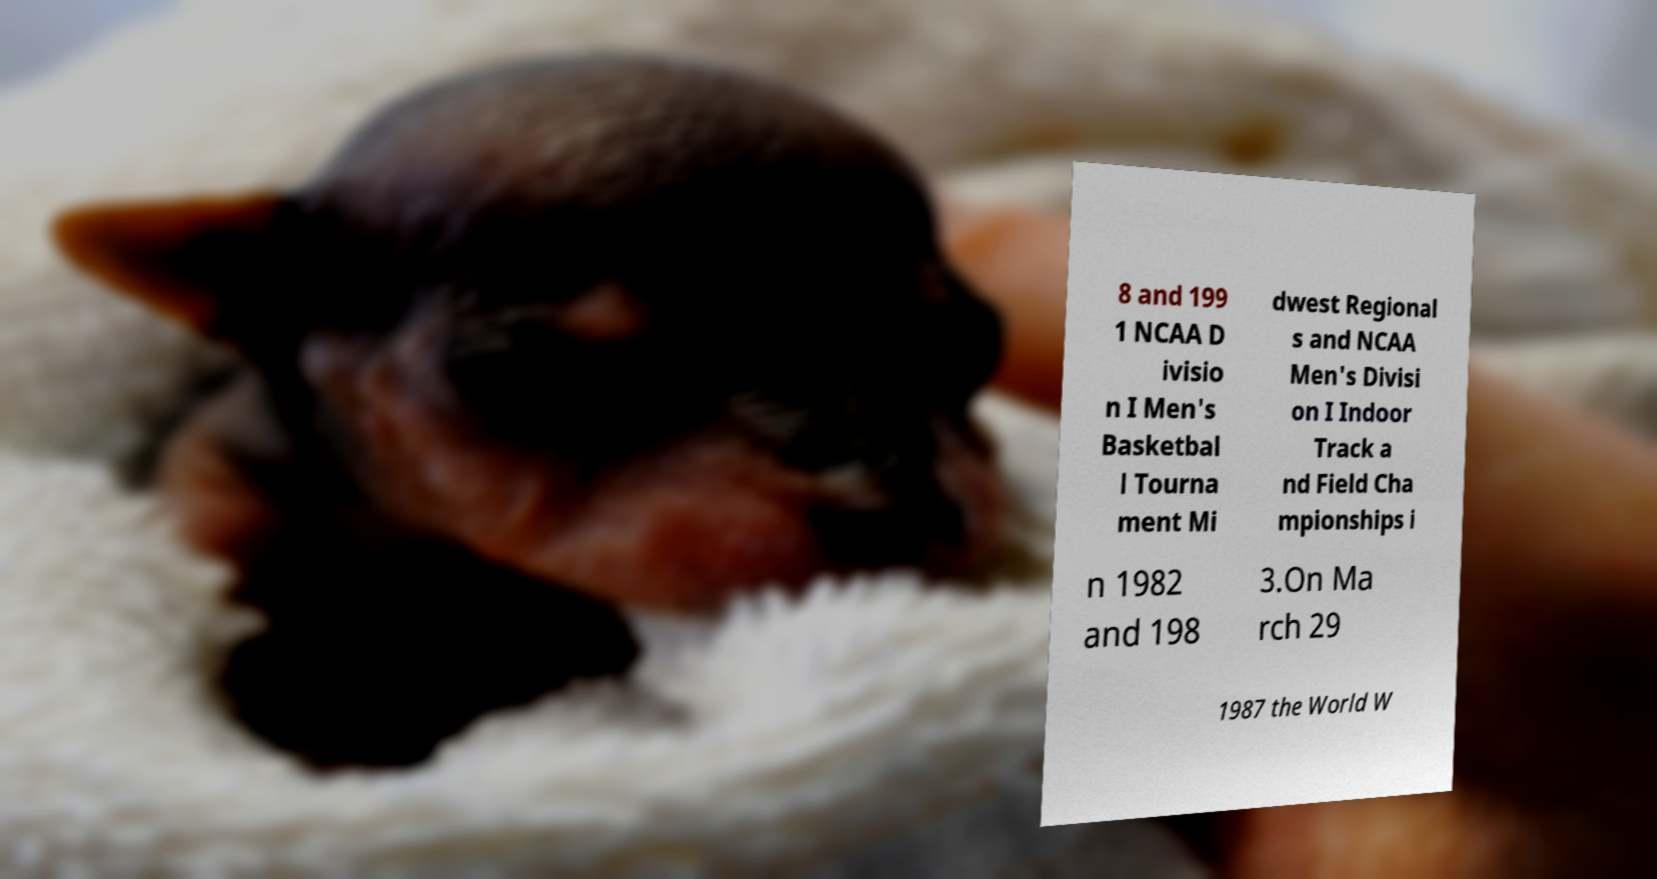Could you assist in decoding the text presented in this image and type it out clearly? 8 and 199 1 NCAA D ivisio n I Men's Basketbal l Tourna ment Mi dwest Regional s and NCAA Men's Divisi on I Indoor Track a nd Field Cha mpionships i n 1982 and 198 3.On Ma rch 29 1987 the World W 